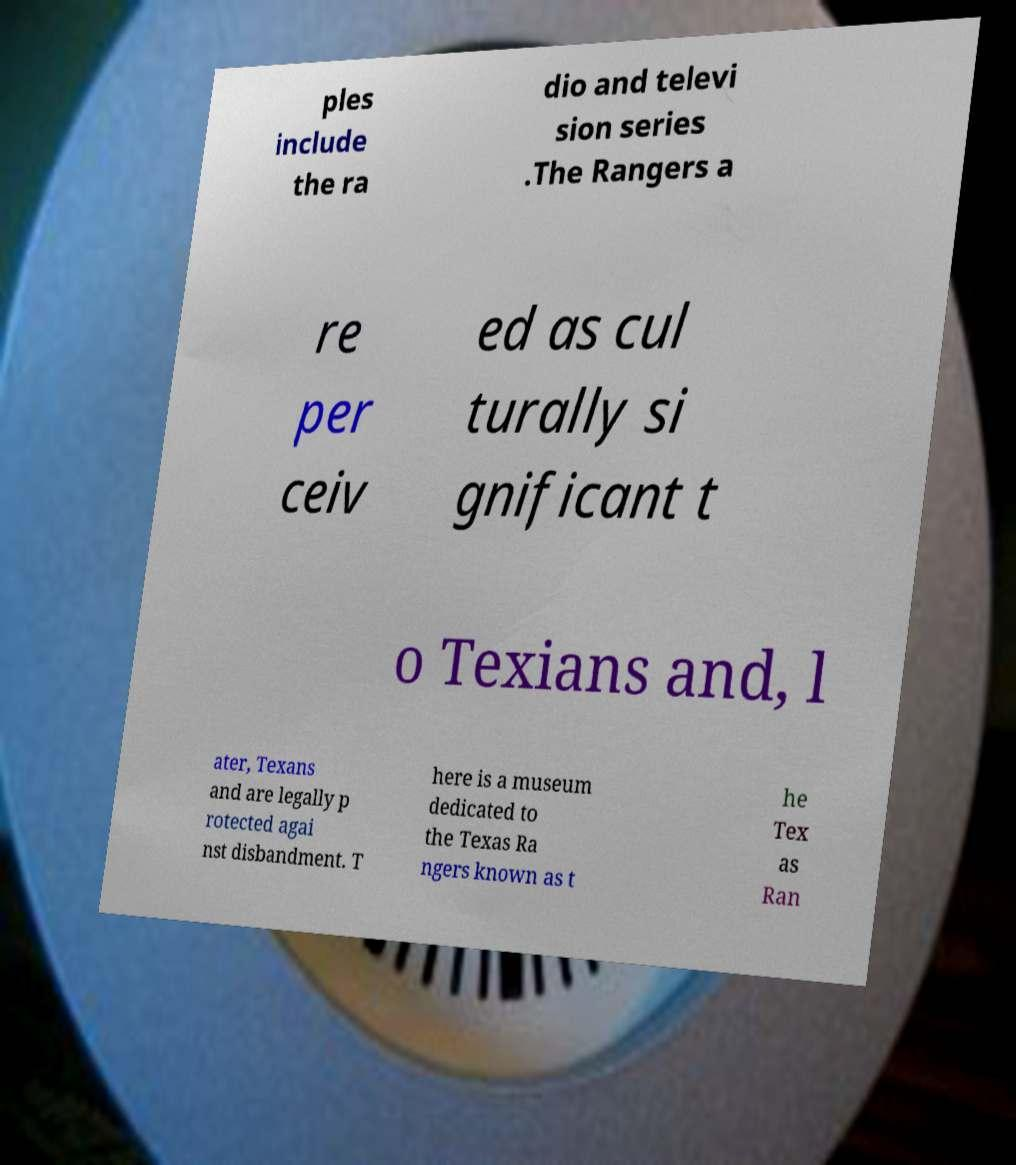There's text embedded in this image that I need extracted. Can you transcribe it verbatim? ples include the ra dio and televi sion series .The Rangers a re per ceiv ed as cul turally si gnificant t o Texians and, l ater, Texans and are legally p rotected agai nst disbandment. T here is a museum dedicated to the Texas Ra ngers known as t he Tex as Ran 